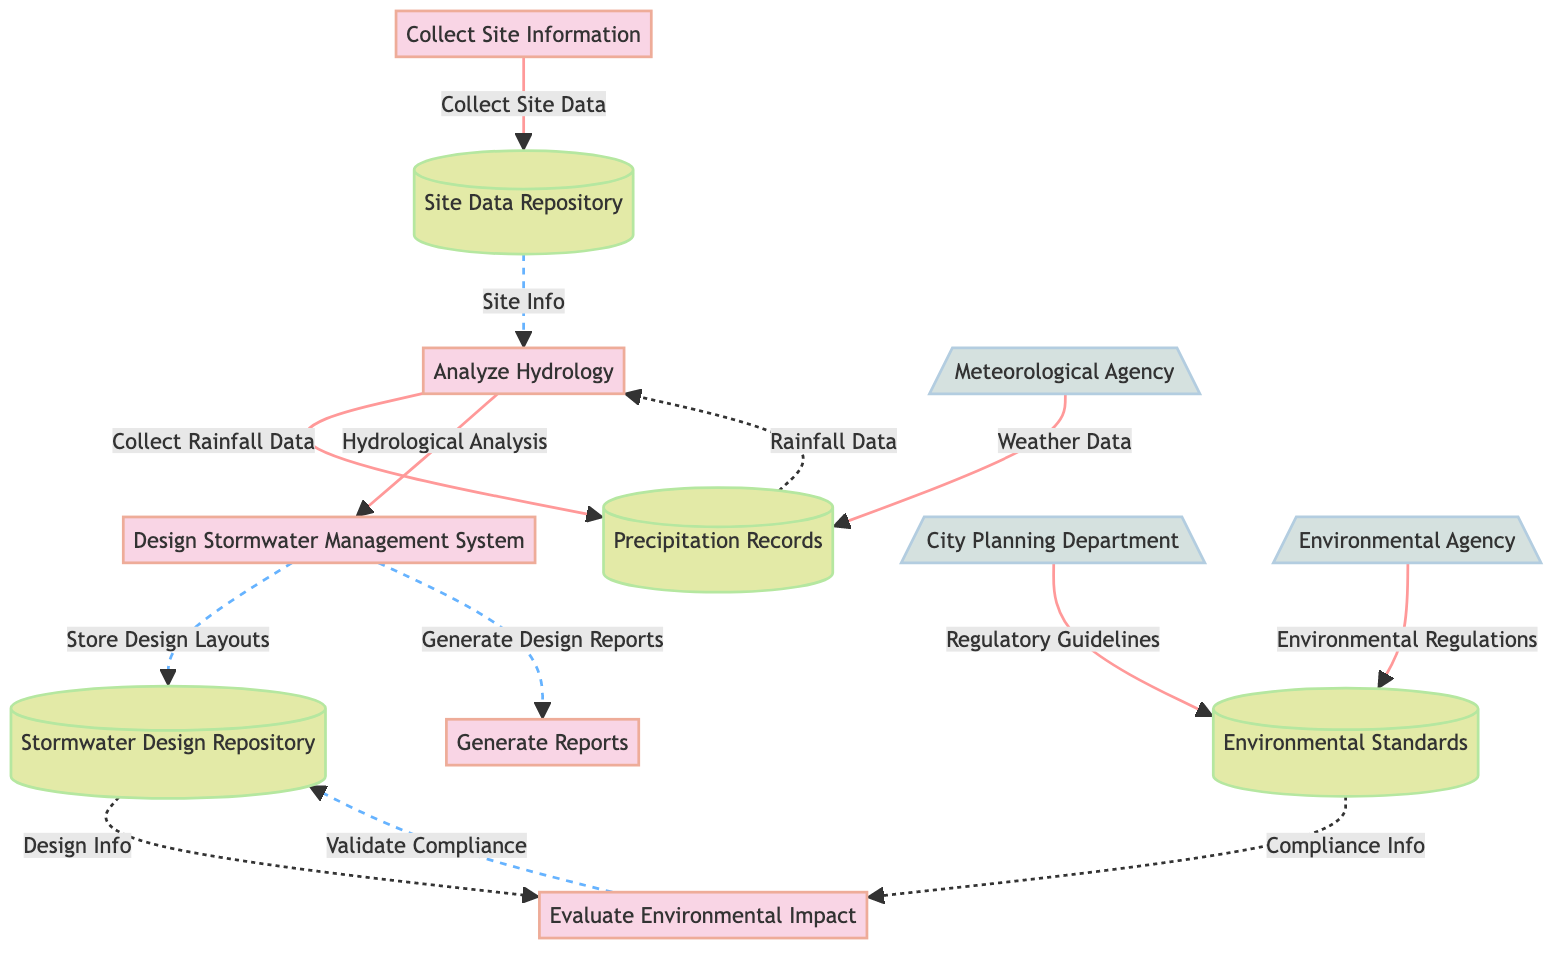What is the first process in the diagram? The first process in the diagram is labeled as "Collect Site Information," which is the initial step in the data flow.
Answer: Collect Site Information How many data stores are represented in the diagram? There are four data stores listed in the diagram: Site Data Repository, Precipitation Records, Stormwater Design Repository, and Environmental Standards.
Answer: 4 Which external entity provides regulatory guidelines? The external entity that provides regulatory guidelines is the "City Planning Department," which is linked to the Environmental Standards data store.
Answer: City Planning Department What is the purpose of the "Analyze Hydrology" process? The purpose of the "Analyze Hydrology" process is to determine rainfall patterns and surface runoff characteristics, enabling further design work.
Answer: Determine rainfall patterns and surface runoff characteristics What data flow results from the "Analyze Hydrology" process to the next process? The data flow from the "Analyze Hydrology" process to the "Design Stormwater Management System" process is labeled as "Hydrological Analysis," which delivers the results of the analysis.
Answer: Hydrological Analysis What data is collected from the Meteorological Agency? The data collected from the Meteorological Agency consists of historical and forecasted weather data, which is crucial for analysis work.
Answer: Weather Data How do environmental standards impact the design process? Environmental standards impact the design process through the "Validate Compliance" flow, where compliance reviews are sent to ensure the designs meet regulatory requirements.
Answer: Validate Compliance Which process generates reports at the end of the data flow? The process responsible for generating reports at the end of the data flow is labeled "Generate Reports," which compiles the design and system updates into formal documentation.
Answer: Generate Reports What does the "Stormwater Design Repository" store? The "Stormwater Design Repository" stores all design, calculations, and layouts for the stormwater management system, serving as a centralized location for design documents.
Answer: All design, calculations, and layouts for the stormwater system 